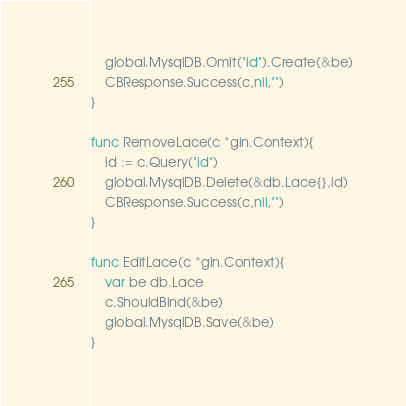<code> <loc_0><loc_0><loc_500><loc_500><_Go_>	global.MysqlDB.Omit("id").Create(&be)
	CBResponse.Success(c,nil,"")
}

func RemoveLace(c *gin.Context){
	id := c.Query("id")
	global.MysqlDB.Delete(&db.Lace{},id)
	CBResponse.Success(c,nil,"")
}

func EditLace(c *gin.Context){
	var be db.Lace
	c.ShouldBind(&be)
	global.MysqlDB.Save(&be)
}

</code> 